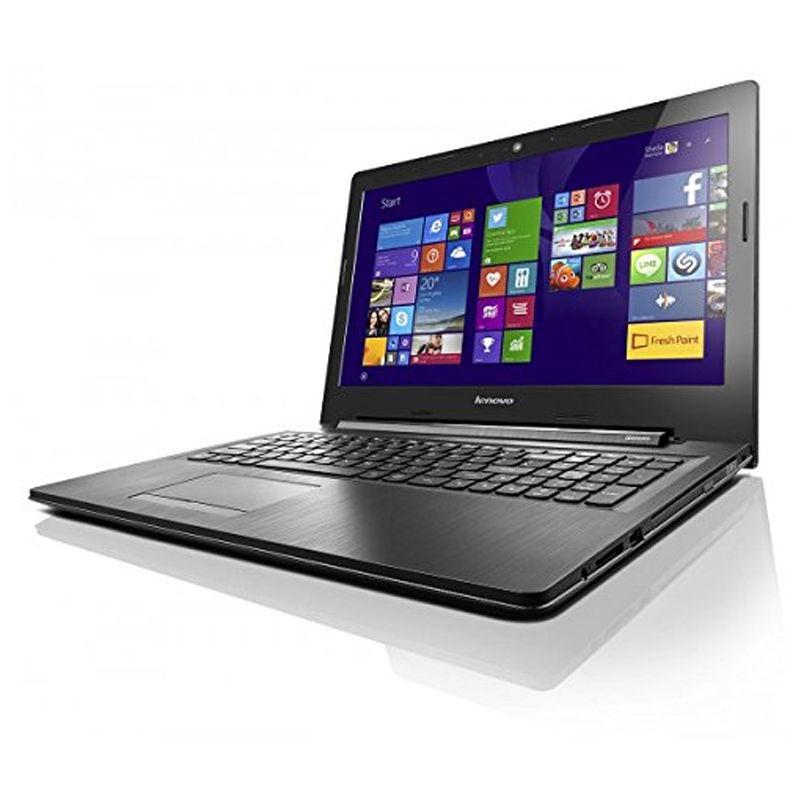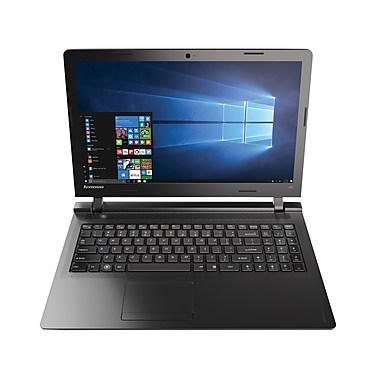The first image is the image on the left, the second image is the image on the right. Considering the images on both sides, is "Each image contains one laptop opened to at least 90-degrees with its screen visible." valid? Answer yes or no. Yes. The first image is the image on the left, the second image is the image on the right. Given the left and right images, does the statement "One of the displays shows a mountain." hold true? Answer yes or no. No. 